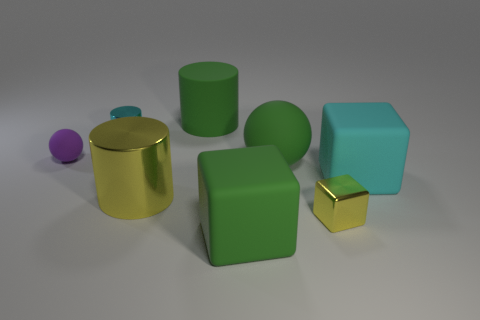Add 1 tiny brown shiny things. How many objects exist? 9 Subtract all balls. How many objects are left? 6 Add 1 small yellow things. How many small yellow things are left? 2 Add 7 tiny cyan metallic objects. How many tiny cyan metallic objects exist? 8 Subtract 0 red cubes. How many objects are left? 8 Subtract all big green cylinders. Subtract all small balls. How many objects are left? 6 